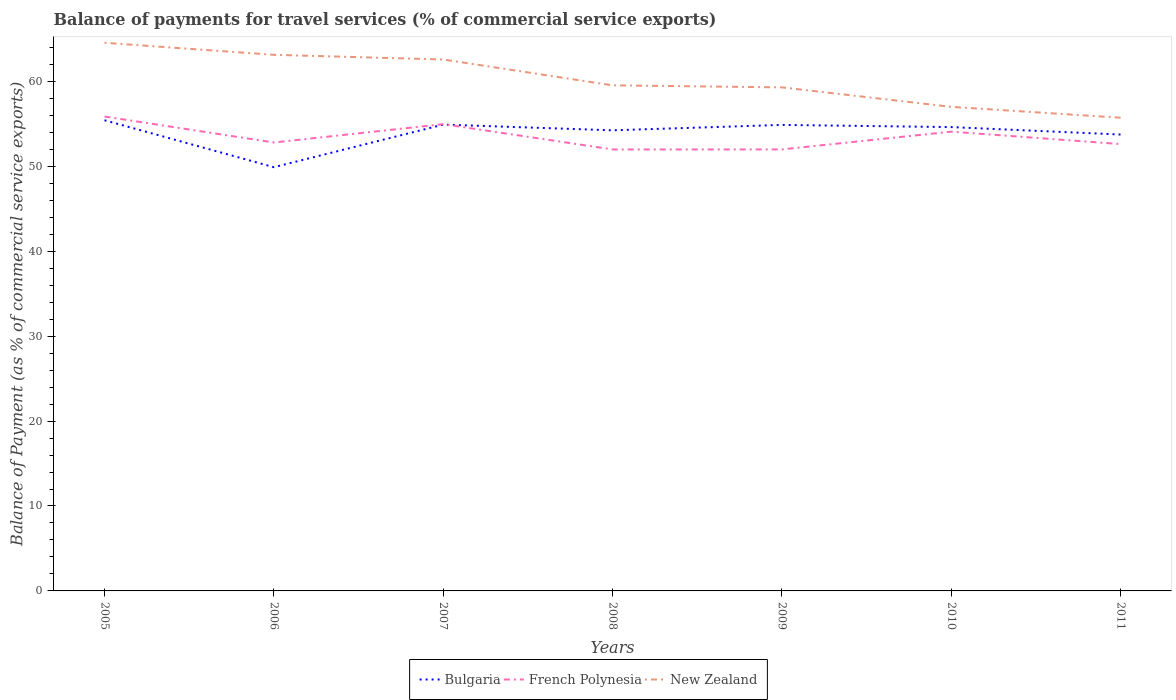How many different coloured lines are there?
Your response must be concise. 3. Across all years, what is the maximum balance of payments for travel services in New Zealand?
Make the answer very short. 55.72. In which year was the balance of payments for travel services in Bulgaria maximum?
Your response must be concise. 2006. What is the total balance of payments for travel services in Bulgaria in the graph?
Your response must be concise. 0.55. What is the difference between the highest and the second highest balance of payments for travel services in New Zealand?
Provide a short and direct response. 8.82. What is the difference between the highest and the lowest balance of payments for travel services in French Polynesia?
Keep it short and to the point. 3. How many years are there in the graph?
Provide a short and direct response. 7. Are the values on the major ticks of Y-axis written in scientific E-notation?
Offer a very short reply. No. Does the graph contain any zero values?
Ensure brevity in your answer.  No. Does the graph contain grids?
Provide a short and direct response. No. Where does the legend appear in the graph?
Your response must be concise. Bottom center. How many legend labels are there?
Ensure brevity in your answer.  3. How are the legend labels stacked?
Offer a very short reply. Horizontal. What is the title of the graph?
Offer a terse response. Balance of payments for travel services (% of commercial service exports). Does "Macedonia" appear as one of the legend labels in the graph?
Give a very brief answer. No. What is the label or title of the Y-axis?
Offer a very short reply. Balance of Payment (as % of commercial service exports). What is the Balance of Payment (as % of commercial service exports) in Bulgaria in 2005?
Provide a short and direct response. 55.42. What is the Balance of Payment (as % of commercial service exports) of French Polynesia in 2005?
Your answer should be very brief. 55.86. What is the Balance of Payment (as % of commercial service exports) of New Zealand in 2005?
Your response must be concise. 64.54. What is the Balance of Payment (as % of commercial service exports) in Bulgaria in 2006?
Offer a very short reply. 49.9. What is the Balance of Payment (as % of commercial service exports) of French Polynesia in 2006?
Your answer should be compact. 52.8. What is the Balance of Payment (as % of commercial service exports) in New Zealand in 2006?
Provide a short and direct response. 63.13. What is the Balance of Payment (as % of commercial service exports) in Bulgaria in 2007?
Make the answer very short. 54.91. What is the Balance of Payment (as % of commercial service exports) of French Polynesia in 2007?
Ensure brevity in your answer.  54.96. What is the Balance of Payment (as % of commercial service exports) of New Zealand in 2007?
Your answer should be very brief. 62.57. What is the Balance of Payment (as % of commercial service exports) of Bulgaria in 2008?
Offer a very short reply. 54.24. What is the Balance of Payment (as % of commercial service exports) in French Polynesia in 2008?
Your answer should be very brief. 51.98. What is the Balance of Payment (as % of commercial service exports) of New Zealand in 2008?
Make the answer very short. 59.53. What is the Balance of Payment (as % of commercial service exports) in Bulgaria in 2009?
Give a very brief answer. 54.87. What is the Balance of Payment (as % of commercial service exports) of French Polynesia in 2009?
Ensure brevity in your answer.  51.99. What is the Balance of Payment (as % of commercial service exports) in New Zealand in 2009?
Ensure brevity in your answer.  59.29. What is the Balance of Payment (as % of commercial service exports) of Bulgaria in 2010?
Offer a very short reply. 54.61. What is the Balance of Payment (as % of commercial service exports) in French Polynesia in 2010?
Give a very brief answer. 54.08. What is the Balance of Payment (as % of commercial service exports) in New Zealand in 2010?
Offer a very short reply. 57. What is the Balance of Payment (as % of commercial service exports) in Bulgaria in 2011?
Keep it short and to the point. 53.74. What is the Balance of Payment (as % of commercial service exports) in French Polynesia in 2011?
Give a very brief answer. 52.61. What is the Balance of Payment (as % of commercial service exports) of New Zealand in 2011?
Offer a very short reply. 55.72. Across all years, what is the maximum Balance of Payment (as % of commercial service exports) of Bulgaria?
Offer a terse response. 55.42. Across all years, what is the maximum Balance of Payment (as % of commercial service exports) in French Polynesia?
Provide a short and direct response. 55.86. Across all years, what is the maximum Balance of Payment (as % of commercial service exports) of New Zealand?
Provide a succinct answer. 64.54. Across all years, what is the minimum Balance of Payment (as % of commercial service exports) in Bulgaria?
Your answer should be compact. 49.9. Across all years, what is the minimum Balance of Payment (as % of commercial service exports) of French Polynesia?
Your answer should be very brief. 51.98. Across all years, what is the minimum Balance of Payment (as % of commercial service exports) in New Zealand?
Your response must be concise. 55.72. What is the total Balance of Payment (as % of commercial service exports) of Bulgaria in the graph?
Give a very brief answer. 377.68. What is the total Balance of Payment (as % of commercial service exports) in French Polynesia in the graph?
Offer a terse response. 374.29. What is the total Balance of Payment (as % of commercial service exports) in New Zealand in the graph?
Provide a short and direct response. 421.78. What is the difference between the Balance of Payment (as % of commercial service exports) of Bulgaria in 2005 and that in 2006?
Provide a succinct answer. 5.52. What is the difference between the Balance of Payment (as % of commercial service exports) in French Polynesia in 2005 and that in 2006?
Provide a short and direct response. 3.06. What is the difference between the Balance of Payment (as % of commercial service exports) in New Zealand in 2005 and that in 2006?
Offer a very short reply. 1.41. What is the difference between the Balance of Payment (as % of commercial service exports) in Bulgaria in 2005 and that in 2007?
Your answer should be very brief. 0.51. What is the difference between the Balance of Payment (as % of commercial service exports) of French Polynesia in 2005 and that in 2007?
Ensure brevity in your answer.  0.9. What is the difference between the Balance of Payment (as % of commercial service exports) in New Zealand in 2005 and that in 2007?
Offer a very short reply. 1.97. What is the difference between the Balance of Payment (as % of commercial service exports) in Bulgaria in 2005 and that in 2008?
Your answer should be compact. 1.18. What is the difference between the Balance of Payment (as % of commercial service exports) of French Polynesia in 2005 and that in 2008?
Your response must be concise. 3.88. What is the difference between the Balance of Payment (as % of commercial service exports) of New Zealand in 2005 and that in 2008?
Make the answer very short. 5.01. What is the difference between the Balance of Payment (as % of commercial service exports) of Bulgaria in 2005 and that in 2009?
Your answer should be very brief. 0.55. What is the difference between the Balance of Payment (as % of commercial service exports) of French Polynesia in 2005 and that in 2009?
Your answer should be compact. 3.87. What is the difference between the Balance of Payment (as % of commercial service exports) of New Zealand in 2005 and that in 2009?
Make the answer very short. 5.25. What is the difference between the Balance of Payment (as % of commercial service exports) of Bulgaria in 2005 and that in 2010?
Ensure brevity in your answer.  0.81. What is the difference between the Balance of Payment (as % of commercial service exports) in French Polynesia in 2005 and that in 2010?
Ensure brevity in your answer.  1.78. What is the difference between the Balance of Payment (as % of commercial service exports) of New Zealand in 2005 and that in 2010?
Provide a short and direct response. 7.54. What is the difference between the Balance of Payment (as % of commercial service exports) of Bulgaria in 2005 and that in 2011?
Give a very brief answer. 1.68. What is the difference between the Balance of Payment (as % of commercial service exports) in French Polynesia in 2005 and that in 2011?
Keep it short and to the point. 3.25. What is the difference between the Balance of Payment (as % of commercial service exports) in New Zealand in 2005 and that in 2011?
Give a very brief answer. 8.82. What is the difference between the Balance of Payment (as % of commercial service exports) in Bulgaria in 2006 and that in 2007?
Give a very brief answer. -5.01. What is the difference between the Balance of Payment (as % of commercial service exports) in French Polynesia in 2006 and that in 2007?
Make the answer very short. -2.16. What is the difference between the Balance of Payment (as % of commercial service exports) in New Zealand in 2006 and that in 2007?
Provide a short and direct response. 0.55. What is the difference between the Balance of Payment (as % of commercial service exports) of Bulgaria in 2006 and that in 2008?
Provide a succinct answer. -4.34. What is the difference between the Balance of Payment (as % of commercial service exports) of French Polynesia in 2006 and that in 2008?
Provide a succinct answer. 0.82. What is the difference between the Balance of Payment (as % of commercial service exports) in New Zealand in 2006 and that in 2008?
Offer a very short reply. 3.59. What is the difference between the Balance of Payment (as % of commercial service exports) of Bulgaria in 2006 and that in 2009?
Make the answer very short. -4.98. What is the difference between the Balance of Payment (as % of commercial service exports) of French Polynesia in 2006 and that in 2009?
Your response must be concise. 0.81. What is the difference between the Balance of Payment (as % of commercial service exports) of New Zealand in 2006 and that in 2009?
Provide a succinct answer. 3.83. What is the difference between the Balance of Payment (as % of commercial service exports) in Bulgaria in 2006 and that in 2010?
Provide a short and direct response. -4.72. What is the difference between the Balance of Payment (as % of commercial service exports) in French Polynesia in 2006 and that in 2010?
Provide a short and direct response. -1.28. What is the difference between the Balance of Payment (as % of commercial service exports) of New Zealand in 2006 and that in 2010?
Keep it short and to the point. 6.13. What is the difference between the Balance of Payment (as % of commercial service exports) of Bulgaria in 2006 and that in 2011?
Give a very brief answer. -3.84. What is the difference between the Balance of Payment (as % of commercial service exports) of French Polynesia in 2006 and that in 2011?
Give a very brief answer. 0.19. What is the difference between the Balance of Payment (as % of commercial service exports) of New Zealand in 2006 and that in 2011?
Your answer should be very brief. 7.41. What is the difference between the Balance of Payment (as % of commercial service exports) in Bulgaria in 2007 and that in 2008?
Give a very brief answer. 0.67. What is the difference between the Balance of Payment (as % of commercial service exports) of French Polynesia in 2007 and that in 2008?
Give a very brief answer. 2.98. What is the difference between the Balance of Payment (as % of commercial service exports) in New Zealand in 2007 and that in 2008?
Make the answer very short. 3.04. What is the difference between the Balance of Payment (as % of commercial service exports) of Bulgaria in 2007 and that in 2009?
Offer a very short reply. 0.04. What is the difference between the Balance of Payment (as % of commercial service exports) of French Polynesia in 2007 and that in 2009?
Offer a terse response. 2.98. What is the difference between the Balance of Payment (as % of commercial service exports) in New Zealand in 2007 and that in 2009?
Ensure brevity in your answer.  3.28. What is the difference between the Balance of Payment (as % of commercial service exports) of Bulgaria in 2007 and that in 2010?
Keep it short and to the point. 0.29. What is the difference between the Balance of Payment (as % of commercial service exports) of French Polynesia in 2007 and that in 2010?
Give a very brief answer. 0.89. What is the difference between the Balance of Payment (as % of commercial service exports) of New Zealand in 2007 and that in 2010?
Provide a short and direct response. 5.57. What is the difference between the Balance of Payment (as % of commercial service exports) in Bulgaria in 2007 and that in 2011?
Keep it short and to the point. 1.17. What is the difference between the Balance of Payment (as % of commercial service exports) of French Polynesia in 2007 and that in 2011?
Offer a terse response. 2.35. What is the difference between the Balance of Payment (as % of commercial service exports) of New Zealand in 2007 and that in 2011?
Keep it short and to the point. 6.86. What is the difference between the Balance of Payment (as % of commercial service exports) in Bulgaria in 2008 and that in 2009?
Give a very brief answer. -0.64. What is the difference between the Balance of Payment (as % of commercial service exports) of French Polynesia in 2008 and that in 2009?
Your answer should be very brief. -0.01. What is the difference between the Balance of Payment (as % of commercial service exports) of New Zealand in 2008 and that in 2009?
Offer a terse response. 0.24. What is the difference between the Balance of Payment (as % of commercial service exports) of Bulgaria in 2008 and that in 2010?
Give a very brief answer. -0.38. What is the difference between the Balance of Payment (as % of commercial service exports) in French Polynesia in 2008 and that in 2010?
Ensure brevity in your answer.  -2.1. What is the difference between the Balance of Payment (as % of commercial service exports) of New Zealand in 2008 and that in 2010?
Keep it short and to the point. 2.53. What is the difference between the Balance of Payment (as % of commercial service exports) of Bulgaria in 2008 and that in 2011?
Your response must be concise. 0.5. What is the difference between the Balance of Payment (as % of commercial service exports) of French Polynesia in 2008 and that in 2011?
Offer a very short reply. -0.63. What is the difference between the Balance of Payment (as % of commercial service exports) of New Zealand in 2008 and that in 2011?
Your answer should be very brief. 3.81. What is the difference between the Balance of Payment (as % of commercial service exports) in Bulgaria in 2009 and that in 2010?
Your answer should be very brief. 0.26. What is the difference between the Balance of Payment (as % of commercial service exports) of French Polynesia in 2009 and that in 2010?
Offer a very short reply. -2.09. What is the difference between the Balance of Payment (as % of commercial service exports) of New Zealand in 2009 and that in 2010?
Make the answer very short. 2.29. What is the difference between the Balance of Payment (as % of commercial service exports) of Bulgaria in 2009 and that in 2011?
Provide a succinct answer. 1.13. What is the difference between the Balance of Payment (as % of commercial service exports) of French Polynesia in 2009 and that in 2011?
Offer a terse response. -0.63. What is the difference between the Balance of Payment (as % of commercial service exports) of New Zealand in 2009 and that in 2011?
Your response must be concise. 3.58. What is the difference between the Balance of Payment (as % of commercial service exports) of Bulgaria in 2010 and that in 2011?
Your answer should be very brief. 0.88. What is the difference between the Balance of Payment (as % of commercial service exports) of French Polynesia in 2010 and that in 2011?
Ensure brevity in your answer.  1.46. What is the difference between the Balance of Payment (as % of commercial service exports) of New Zealand in 2010 and that in 2011?
Your answer should be compact. 1.28. What is the difference between the Balance of Payment (as % of commercial service exports) of Bulgaria in 2005 and the Balance of Payment (as % of commercial service exports) of French Polynesia in 2006?
Offer a terse response. 2.62. What is the difference between the Balance of Payment (as % of commercial service exports) of Bulgaria in 2005 and the Balance of Payment (as % of commercial service exports) of New Zealand in 2006?
Make the answer very short. -7.71. What is the difference between the Balance of Payment (as % of commercial service exports) in French Polynesia in 2005 and the Balance of Payment (as % of commercial service exports) in New Zealand in 2006?
Your answer should be very brief. -7.27. What is the difference between the Balance of Payment (as % of commercial service exports) in Bulgaria in 2005 and the Balance of Payment (as % of commercial service exports) in French Polynesia in 2007?
Provide a succinct answer. 0.46. What is the difference between the Balance of Payment (as % of commercial service exports) of Bulgaria in 2005 and the Balance of Payment (as % of commercial service exports) of New Zealand in 2007?
Keep it short and to the point. -7.15. What is the difference between the Balance of Payment (as % of commercial service exports) in French Polynesia in 2005 and the Balance of Payment (as % of commercial service exports) in New Zealand in 2007?
Your response must be concise. -6.71. What is the difference between the Balance of Payment (as % of commercial service exports) of Bulgaria in 2005 and the Balance of Payment (as % of commercial service exports) of French Polynesia in 2008?
Provide a succinct answer. 3.44. What is the difference between the Balance of Payment (as % of commercial service exports) of Bulgaria in 2005 and the Balance of Payment (as % of commercial service exports) of New Zealand in 2008?
Ensure brevity in your answer.  -4.11. What is the difference between the Balance of Payment (as % of commercial service exports) of French Polynesia in 2005 and the Balance of Payment (as % of commercial service exports) of New Zealand in 2008?
Keep it short and to the point. -3.67. What is the difference between the Balance of Payment (as % of commercial service exports) of Bulgaria in 2005 and the Balance of Payment (as % of commercial service exports) of French Polynesia in 2009?
Ensure brevity in your answer.  3.43. What is the difference between the Balance of Payment (as % of commercial service exports) in Bulgaria in 2005 and the Balance of Payment (as % of commercial service exports) in New Zealand in 2009?
Your response must be concise. -3.87. What is the difference between the Balance of Payment (as % of commercial service exports) of French Polynesia in 2005 and the Balance of Payment (as % of commercial service exports) of New Zealand in 2009?
Keep it short and to the point. -3.43. What is the difference between the Balance of Payment (as % of commercial service exports) in Bulgaria in 2005 and the Balance of Payment (as % of commercial service exports) in French Polynesia in 2010?
Ensure brevity in your answer.  1.34. What is the difference between the Balance of Payment (as % of commercial service exports) of Bulgaria in 2005 and the Balance of Payment (as % of commercial service exports) of New Zealand in 2010?
Provide a short and direct response. -1.58. What is the difference between the Balance of Payment (as % of commercial service exports) of French Polynesia in 2005 and the Balance of Payment (as % of commercial service exports) of New Zealand in 2010?
Keep it short and to the point. -1.14. What is the difference between the Balance of Payment (as % of commercial service exports) of Bulgaria in 2005 and the Balance of Payment (as % of commercial service exports) of French Polynesia in 2011?
Provide a succinct answer. 2.81. What is the difference between the Balance of Payment (as % of commercial service exports) of Bulgaria in 2005 and the Balance of Payment (as % of commercial service exports) of New Zealand in 2011?
Provide a short and direct response. -0.3. What is the difference between the Balance of Payment (as % of commercial service exports) of French Polynesia in 2005 and the Balance of Payment (as % of commercial service exports) of New Zealand in 2011?
Make the answer very short. 0.14. What is the difference between the Balance of Payment (as % of commercial service exports) in Bulgaria in 2006 and the Balance of Payment (as % of commercial service exports) in French Polynesia in 2007?
Provide a succinct answer. -5.07. What is the difference between the Balance of Payment (as % of commercial service exports) of Bulgaria in 2006 and the Balance of Payment (as % of commercial service exports) of New Zealand in 2007?
Provide a short and direct response. -12.68. What is the difference between the Balance of Payment (as % of commercial service exports) in French Polynesia in 2006 and the Balance of Payment (as % of commercial service exports) in New Zealand in 2007?
Offer a terse response. -9.77. What is the difference between the Balance of Payment (as % of commercial service exports) in Bulgaria in 2006 and the Balance of Payment (as % of commercial service exports) in French Polynesia in 2008?
Provide a short and direct response. -2.09. What is the difference between the Balance of Payment (as % of commercial service exports) of Bulgaria in 2006 and the Balance of Payment (as % of commercial service exports) of New Zealand in 2008?
Provide a succinct answer. -9.64. What is the difference between the Balance of Payment (as % of commercial service exports) in French Polynesia in 2006 and the Balance of Payment (as % of commercial service exports) in New Zealand in 2008?
Offer a very short reply. -6.73. What is the difference between the Balance of Payment (as % of commercial service exports) of Bulgaria in 2006 and the Balance of Payment (as % of commercial service exports) of French Polynesia in 2009?
Ensure brevity in your answer.  -2.09. What is the difference between the Balance of Payment (as % of commercial service exports) of Bulgaria in 2006 and the Balance of Payment (as % of commercial service exports) of New Zealand in 2009?
Offer a very short reply. -9.4. What is the difference between the Balance of Payment (as % of commercial service exports) of French Polynesia in 2006 and the Balance of Payment (as % of commercial service exports) of New Zealand in 2009?
Ensure brevity in your answer.  -6.49. What is the difference between the Balance of Payment (as % of commercial service exports) in Bulgaria in 2006 and the Balance of Payment (as % of commercial service exports) in French Polynesia in 2010?
Provide a short and direct response. -4.18. What is the difference between the Balance of Payment (as % of commercial service exports) of Bulgaria in 2006 and the Balance of Payment (as % of commercial service exports) of New Zealand in 2010?
Ensure brevity in your answer.  -7.1. What is the difference between the Balance of Payment (as % of commercial service exports) of French Polynesia in 2006 and the Balance of Payment (as % of commercial service exports) of New Zealand in 2010?
Ensure brevity in your answer.  -4.2. What is the difference between the Balance of Payment (as % of commercial service exports) of Bulgaria in 2006 and the Balance of Payment (as % of commercial service exports) of French Polynesia in 2011?
Make the answer very short. -2.72. What is the difference between the Balance of Payment (as % of commercial service exports) of Bulgaria in 2006 and the Balance of Payment (as % of commercial service exports) of New Zealand in 2011?
Offer a terse response. -5.82. What is the difference between the Balance of Payment (as % of commercial service exports) of French Polynesia in 2006 and the Balance of Payment (as % of commercial service exports) of New Zealand in 2011?
Provide a succinct answer. -2.92. What is the difference between the Balance of Payment (as % of commercial service exports) in Bulgaria in 2007 and the Balance of Payment (as % of commercial service exports) in French Polynesia in 2008?
Give a very brief answer. 2.92. What is the difference between the Balance of Payment (as % of commercial service exports) of Bulgaria in 2007 and the Balance of Payment (as % of commercial service exports) of New Zealand in 2008?
Offer a very short reply. -4.62. What is the difference between the Balance of Payment (as % of commercial service exports) in French Polynesia in 2007 and the Balance of Payment (as % of commercial service exports) in New Zealand in 2008?
Ensure brevity in your answer.  -4.57. What is the difference between the Balance of Payment (as % of commercial service exports) of Bulgaria in 2007 and the Balance of Payment (as % of commercial service exports) of French Polynesia in 2009?
Provide a short and direct response. 2.92. What is the difference between the Balance of Payment (as % of commercial service exports) of Bulgaria in 2007 and the Balance of Payment (as % of commercial service exports) of New Zealand in 2009?
Ensure brevity in your answer.  -4.38. What is the difference between the Balance of Payment (as % of commercial service exports) in French Polynesia in 2007 and the Balance of Payment (as % of commercial service exports) in New Zealand in 2009?
Provide a succinct answer. -4.33. What is the difference between the Balance of Payment (as % of commercial service exports) of Bulgaria in 2007 and the Balance of Payment (as % of commercial service exports) of French Polynesia in 2010?
Keep it short and to the point. 0.83. What is the difference between the Balance of Payment (as % of commercial service exports) of Bulgaria in 2007 and the Balance of Payment (as % of commercial service exports) of New Zealand in 2010?
Provide a short and direct response. -2.09. What is the difference between the Balance of Payment (as % of commercial service exports) of French Polynesia in 2007 and the Balance of Payment (as % of commercial service exports) of New Zealand in 2010?
Your response must be concise. -2.04. What is the difference between the Balance of Payment (as % of commercial service exports) of Bulgaria in 2007 and the Balance of Payment (as % of commercial service exports) of French Polynesia in 2011?
Your response must be concise. 2.29. What is the difference between the Balance of Payment (as % of commercial service exports) of Bulgaria in 2007 and the Balance of Payment (as % of commercial service exports) of New Zealand in 2011?
Keep it short and to the point. -0.81. What is the difference between the Balance of Payment (as % of commercial service exports) in French Polynesia in 2007 and the Balance of Payment (as % of commercial service exports) in New Zealand in 2011?
Your answer should be compact. -0.75. What is the difference between the Balance of Payment (as % of commercial service exports) in Bulgaria in 2008 and the Balance of Payment (as % of commercial service exports) in French Polynesia in 2009?
Your answer should be compact. 2.25. What is the difference between the Balance of Payment (as % of commercial service exports) in Bulgaria in 2008 and the Balance of Payment (as % of commercial service exports) in New Zealand in 2009?
Your answer should be compact. -5.06. What is the difference between the Balance of Payment (as % of commercial service exports) of French Polynesia in 2008 and the Balance of Payment (as % of commercial service exports) of New Zealand in 2009?
Your answer should be compact. -7.31. What is the difference between the Balance of Payment (as % of commercial service exports) of Bulgaria in 2008 and the Balance of Payment (as % of commercial service exports) of French Polynesia in 2010?
Your response must be concise. 0.16. What is the difference between the Balance of Payment (as % of commercial service exports) in Bulgaria in 2008 and the Balance of Payment (as % of commercial service exports) in New Zealand in 2010?
Provide a short and direct response. -2.76. What is the difference between the Balance of Payment (as % of commercial service exports) of French Polynesia in 2008 and the Balance of Payment (as % of commercial service exports) of New Zealand in 2010?
Your answer should be very brief. -5.02. What is the difference between the Balance of Payment (as % of commercial service exports) of Bulgaria in 2008 and the Balance of Payment (as % of commercial service exports) of French Polynesia in 2011?
Ensure brevity in your answer.  1.62. What is the difference between the Balance of Payment (as % of commercial service exports) in Bulgaria in 2008 and the Balance of Payment (as % of commercial service exports) in New Zealand in 2011?
Your answer should be compact. -1.48. What is the difference between the Balance of Payment (as % of commercial service exports) of French Polynesia in 2008 and the Balance of Payment (as % of commercial service exports) of New Zealand in 2011?
Keep it short and to the point. -3.73. What is the difference between the Balance of Payment (as % of commercial service exports) in Bulgaria in 2009 and the Balance of Payment (as % of commercial service exports) in French Polynesia in 2010?
Provide a succinct answer. 0.79. What is the difference between the Balance of Payment (as % of commercial service exports) in Bulgaria in 2009 and the Balance of Payment (as % of commercial service exports) in New Zealand in 2010?
Your answer should be compact. -2.13. What is the difference between the Balance of Payment (as % of commercial service exports) in French Polynesia in 2009 and the Balance of Payment (as % of commercial service exports) in New Zealand in 2010?
Provide a short and direct response. -5.01. What is the difference between the Balance of Payment (as % of commercial service exports) of Bulgaria in 2009 and the Balance of Payment (as % of commercial service exports) of French Polynesia in 2011?
Your answer should be very brief. 2.26. What is the difference between the Balance of Payment (as % of commercial service exports) in Bulgaria in 2009 and the Balance of Payment (as % of commercial service exports) in New Zealand in 2011?
Give a very brief answer. -0.85. What is the difference between the Balance of Payment (as % of commercial service exports) in French Polynesia in 2009 and the Balance of Payment (as % of commercial service exports) in New Zealand in 2011?
Keep it short and to the point. -3.73. What is the difference between the Balance of Payment (as % of commercial service exports) of Bulgaria in 2010 and the Balance of Payment (as % of commercial service exports) of French Polynesia in 2011?
Your answer should be very brief. 2. What is the difference between the Balance of Payment (as % of commercial service exports) in Bulgaria in 2010 and the Balance of Payment (as % of commercial service exports) in New Zealand in 2011?
Make the answer very short. -1.1. What is the difference between the Balance of Payment (as % of commercial service exports) of French Polynesia in 2010 and the Balance of Payment (as % of commercial service exports) of New Zealand in 2011?
Your answer should be very brief. -1.64. What is the average Balance of Payment (as % of commercial service exports) in Bulgaria per year?
Give a very brief answer. 53.95. What is the average Balance of Payment (as % of commercial service exports) of French Polynesia per year?
Your answer should be compact. 53.47. What is the average Balance of Payment (as % of commercial service exports) of New Zealand per year?
Offer a very short reply. 60.25. In the year 2005, what is the difference between the Balance of Payment (as % of commercial service exports) of Bulgaria and Balance of Payment (as % of commercial service exports) of French Polynesia?
Provide a succinct answer. -0.44. In the year 2005, what is the difference between the Balance of Payment (as % of commercial service exports) in Bulgaria and Balance of Payment (as % of commercial service exports) in New Zealand?
Give a very brief answer. -9.12. In the year 2005, what is the difference between the Balance of Payment (as % of commercial service exports) of French Polynesia and Balance of Payment (as % of commercial service exports) of New Zealand?
Offer a terse response. -8.68. In the year 2006, what is the difference between the Balance of Payment (as % of commercial service exports) of Bulgaria and Balance of Payment (as % of commercial service exports) of French Polynesia?
Keep it short and to the point. -2.91. In the year 2006, what is the difference between the Balance of Payment (as % of commercial service exports) of Bulgaria and Balance of Payment (as % of commercial service exports) of New Zealand?
Make the answer very short. -13.23. In the year 2006, what is the difference between the Balance of Payment (as % of commercial service exports) in French Polynesia and Balance of Payment (as % of commercial service exports) in New Zealand?
Your response must be concise. -10.32. In the year 2007, what is the difference between the Balance of Payment (as % of commercial service exports) of Bulgaria and Balance of Payment (as % of commercial service exports) of French Polynesia?
Your answer should be very brief. -0.06. In the year 2007, what is the difference between the Balance of Payment (as % of commercial service exports) in Bulgaria and Balance of Payment (as % of commercial service exports) in New Zealand?
Your answer should be compact. -7.67. In the year 2007, what is the difference between the Balance of Payment (as % of commercial service exports) in French Polynesia and Balance of Payment (as % of commercial service exports) in New Zealand?
Keep it short and to the point. -7.61. In the year 2008, what is the difference between the Balance of Payment (as % of commercial service exports) in Bulgaria and Balance of Payment (as % of commercial service exports) in French Polynesia?
Give a very brief answer. 2.25. In the year 2008, what is the difference between the Balance of Payment (as % of commercial service exports) in Bulgaria and Balance of Payment (as % of commercial service exports) in New Zealand?
Your response must be concise. -5.3. In the year 2008, what is the difference between the Balance of Payment (as % of commercial service exports) of French Polynesia and Balance of Payment (as % of commercial service exports) of New Zealand?
Your response must be concise. -7.55. In the year 2009, what is the difference between the Balance of Payment (as % of commercial service exports) in Bulgaria and Balance of Payment (as % of commercial service exports) in French Polynesia?
Keep it short and to the point. 2.88. In the year 2009, what is the difference between the Balance of Payment (as % of commercial service exports) of Bulgaria and Balance of Payment (as % of commercial service exports) of New Zealand?
Your answer should be very brief. -4.42. In the year 2009, what is the difference between the Balance of Payment (as % of commercial service exports) of French Polynesia and Balance of Payment (as % of commercial service exports) of New Zealand?
Offer a terse response. -7.3. In the year 2010, what is the difference between the Balance of Payment (as % of commercial service exports) of Bulgaria and Balance of Payment (as % of commercial service exports) of French Polynesia?
Provide a short and direct response. 0.54. In the year 2010, what is the difference between the Balance of Payment (as % of commercial service exports) of Bulgaria and Balance of Payment (as % of commercial service exports) of New Zealand?
Your answer should be compact. -2.38. In the year 2010, what is the difference between the Balance of Payment (as % of commercial service exports) in French Polynesia and Balance of Payment (as % of commercial service exports) in New Zealand?
Ensure brevity in your answer.  -2.92. In the year 2011, what is the difference between the Balance of Payment (as % of commercial service exports) in Bulgaria and Balance of Payment (as % of commercial service exports) in French Polynesia?
Give a very brief answer. 1.12. In the year 2011, what is the difference between the Balance of Payment (as % of commercial service exports) in Bulgaria and Balance of Payment (as % of commercial service exports) in New Zealand?
Offer a terse response. -1.98. In the year 2011, what is the difference between the Balance of Payment (as % of commercial service exports) in French Polynesia and Balance of Payment (as % of commercial service exports) in New Zealand?
Your answer should be very brief. -3.1. What is the ratio of the Balance of Payment (as % of commercial service exports) of Bulgaria in 2005 to that in 2006?
Your response must be concise. 1.11. What is the ratio of the Balance of Payment (as % of commercial service exports) of French Polynesia in 2005 to that in 2006?
Provide a succinct answer. 1.06. What is the ratio of the Balance of Payment (as % of commercial service exports) in New Zealand in 2005 to that in 2006?
Give a very brief answer. 1.02. What is the ratio of the Balance of Payment (as % of commercial service exports) in Bulgaria in 2005 to that in 2007?
Your answer should be compact. 1.01. What is the ratio of the Balance of Payment (as % of commercial service exports) in French Polynesia in 2005 to that in 2007?
Offer a terse response. 1.02. What is the ratio of the Balance of Payment (as % of commercial service exports) of New Zealand in 2005 to that in 2007?
Make the answer very short. 1.03. What is the ratio of the Balance of Payment (as % of commercial service exports) of Bulgaria in 2005 to that in 2008?
Provide a short and direct response. 1.02. What is the ratio of the Balance of Payment (as % of commercial service exports) of French Polynesia in 2005 to that in 2008?
Ensure brevity in your answer.  1.07. What is the ratio of the Balance of Payment (as % of commercial service exports) in New Zealand in 2005 to that in 2008?
Offer a terse response. 1.08. What is the ratio of the Balance of Payment (as % of commercial service exports) in Bulgaria in 2005 to that in 2009?
Provide a short and direct response. 1.01. What is the ratio of the Balance of Payment (as % of commercial service exports) of French Polynesia in 2005 to that in 2009?
Provide a succinct answer. 1.07. What is the ratio of the Balance of Payment (as % of commercial service exports) in New Zealand in 2005 to that in 2009?
Offer a very short reply. 1.09. What is the ratio of the Balance of Payment (as % of commercial service exports) in Bulgaria in 2005 to that in 2010?
Provide a short and direct response. 1.01. What is the ratio of the Balance of Payment (as % of commercial service exports) in French Polynesia in 2005 to that in 2010?
Ensure brevity in your answer.  1.03. What is the ratio of the Balance of Payment (as % of commercial service exports) in New Zealand in 2005 to that in 2010?
Your answer should be compact. 1.13. What is the ratio of the Balance of Payment (as % of commercial service exports) of Bulgaria in 2005 to that in 2011?
Provide a short and direct response. 1.03. What is the ratio of the Balance of Payment (as % of commercial service exports) of French Polynesia in 2005 to that in 2011?
Keep it short and to the point. 1.06. What is the ratio of the Balance of Payment (as % of commercial service exports) of New Zealand in 2005 to that in 2011?
Your answer should be compact. 1.16. What is the ratio of the Balance of Payment (as % of commercial service exports) in Bulgaria in 2006 to that in 2007?
Your answer should be very brief. 0.91. What is the ratio of the Balance of Payment (as % of commercial service exports) of French Polynesia in 2006 to that in 2007?
Your answer should be very brief. 0.96. What is the ratio of the Balance of Payment (as % of commercial service exports) in New Zealand in 2006 to that in 2007?
Provide a short and direct response. 1.01. What is the ratio of the Balance of Payment (as % of commercial service exports) in Bulgaria in 2006 to that in 2008?
Your answer should be compact. 0.92. What is the ratio of the Balance of Payment (as % of commercial service exports) of French Polynesia in 2006 to that in 2008?
Give a very brief answer. 1.02. What is the ratio of the Balance of Payment (as % of commercial service exports) of New Zealand in 2006 to that in 2008?
Make the answer very short. 1.06. What is the ratio of the Balance of Payment (as % of commercial service exports) of Bulgaria in 2006 to that in 2009?
Provide a succinct answer. 0.91. What is the ratio of the Balance of Payment (as % of commercial service exports) of French Polynesia in 2006 to that in 2009?
Provide a short and direct response. 1.02. What is the ratio of the Balance of Payment (as % of commercial service exports) of New Zealand in 2006 to that in 2009?
Your answer should be very brief. 1.06. What is the ratio of the Balance of Payment (as % of commercial service exports) of Bulgaria in 2006 to that in 2010?
Your answer should be compact. 0.91. What is the ratio of the Balance of Payment (as % of commercial service exports) of French Polynesia in 2006 to that in 2010?
Your answer should be very brief. 0.98. What is the ratio of the Balance of Payment (as % of commercial service exports) of New Zealand in 2006 to that in 2010?
Provide a succinct answer. 1.11. What is the ratio of the Balance of Payment (as % of commercial service exports) of Bulgaria in 2006 to that in 2011?
Make the answer very short. 0.93. What is the ratio of the Balance of Payment (as % of commercial service exports) of French Polynesia in 2006 to that in 2011?
Keep it short and to the point. 1. What is the ratio of the Balance of Payment (as % of commercial service exports) of New Zealand in 2006 to that in 2011?
Your answer should be very brief. 1.13. What is the ratio of the Balance of Payment (as % of commercial service exports) in Bulgaria in 2007 to that in 2008?
Make the answer very short. 1.01. What is the ratio of the Balance of Payment (as % of commercial service exports) of French Polynesia in 2007 to that in 2008?
Offer a very short reply. 1.06. What is the ratio of the Balance of Payment (as % of commercial service exports) in New Zealand in 2007 to that in 2008?
Ensure brevity in your answer.  1.05. What is the ratio of the Balance of Payment (as % of commercial service exports) of Bulgaria in 2007 to that in 2009?
Your response must be concise. 1. What is the ratio of the Balance of Payment (as % of commercial service exports) in French Polynesia in 2007 to that in 2009?
Provide a short and direct response. 1.06. What is the ratio of the Balance of Payment (as % of commercial service exports) of New Zealand in 2007 to that in 2009?
Provide a short and direct response. 1.06. What is the ratio of the Balance of Payment (as % of commercial service exports) of Bulgaria in 2007 to that in 2010?
Give a very brief answer. 1.01. What is the ratio of the Balance of Payment (as % of commercial service exports) in French Polynesia in 2007 to that in 2010?
Give a very brief answer. 1.02. What is the ratio of the Balance of Payment (as % of commercial service exports) of New Zealand in 2007 to that in 2010?
Provide a succinct answer. 1.1. What is the ratio of the Balance of Payment (as % of commercial service exports) of Bulgaria in 2007 to that in 2011?
Keep it short and to the point. 1.02. What is the ratio of the Balance of Payment (as % of commercial service exports) in French Polynesia in 2007 to that in 2011?
Your response must be concise. 1.04. What is the ratio of the Balance of Payment (as % of commercial service exports) of New Zealand in 2007 to that in 2011?
Provide a succinct answer. 1.12. What is the ratio of the Balance of Payment (as % of commercial service exports) of Bulgaria in 2008 to that in 2009?
Give a very brief answer. 0.99. What is the ratio of the Balance of Payment (as % of commercial service exports) of New Zealand in 2008 to that in 2009?
Give a very brief answer. 1. What is the ratio of the Balance of Payment (as % of commercial service exports) in Bulgaria in 2008 to that in 2010?
Make the answer very short. 0.99. What is the ratio of the Balance of Payment (as % of commercial service exports) in French Polynesia in 2008 to that in 2010?
Your answer should be compact. 0.96. What is the ratio of the Balance of Payment (as % of commercial service exports) in New Zealand in 2008 to that in 2010?
Keep it short and to the point. 1.04. What is the ratio of the Balance of Payment (as % of commercial service exports) in Bulgaria in 2008 to that in 2011?
Your response must be concise. 1.01. What is the ratio of the Balance of Payment (as % of commercial service exports) in New Zealand in 2008 to that in 2011?
Provide a short and direct response. 1.07. What is the ratio of the Balance of Payment (as % of commercial service exports) of Bulgaria in 2009 to that in 2010?
Offer a very short reply. 1. What is the ratio of the Balance of Payment (as % of commercial service exports) of French Polynesia in 2009 to that in 2010?
Keep it short and to the point. 0.96. What is the ratio of the Balance of Payment (as % of commercial service exports) in New Zealand in 2009 to that in 2010?
Your answer should be very brief. 1.04. What is the ratio of the Balance of Payment (as % of commercial service exports) of Bulgaria in 2009 to that in 2011?
Offer a terse response. 1.02. What is the ratio of the Balance of Payment (as % of commercial service exports) in French Polynesia in 2009 to that in 2011?
Provide a succinct answer. 0.99. What is the ratio of the Balance of Payment (as % of commercial service exports) of New Zealand in 2009 to that in 2011?
Keep it short and to the point. 1.06. What is the ratio of the Balance of Payment (as % of commercial service exports) in Bulgaria in 2010 to that in 2011?
Ensure brevity in your answer.  1.02. What is the ratio of the Balance of Payment (as % of commercial service exports) of French Polynesia in 2010 to that in 2011?
Your answer should be very brief. 1.03. What is the difference between the highest and the second highest Balance of Payment (as % of commercial service exports) of Bulgaria?
Your answer should be compact. 0.51. What is the difference between the highest and the second highest Balance of Payment (as % of commercial service exports) of French Polynesia?
Keep it short and to the point. 0.9. What is the difference between the highest and the second highest Balance of Payment (as % of commercial service exports) in New Zealand?
Your response must be concise. 1.41. What is the difference between the highest and the lowest Balance of Payment (as % of commercial service exports) of Bulgaria?
Give a very brief answer. 5.52. What is the difference between the highest and the lowest Balance of Payment (as % of commercial service exports) in French Polynesia?
Offer a very short reply. 3.88. What is the difference between the highest and the lowest Balance of Payment (as % of commercial service exports) of New Zealand?
Offer a very short reply. 8.82. 